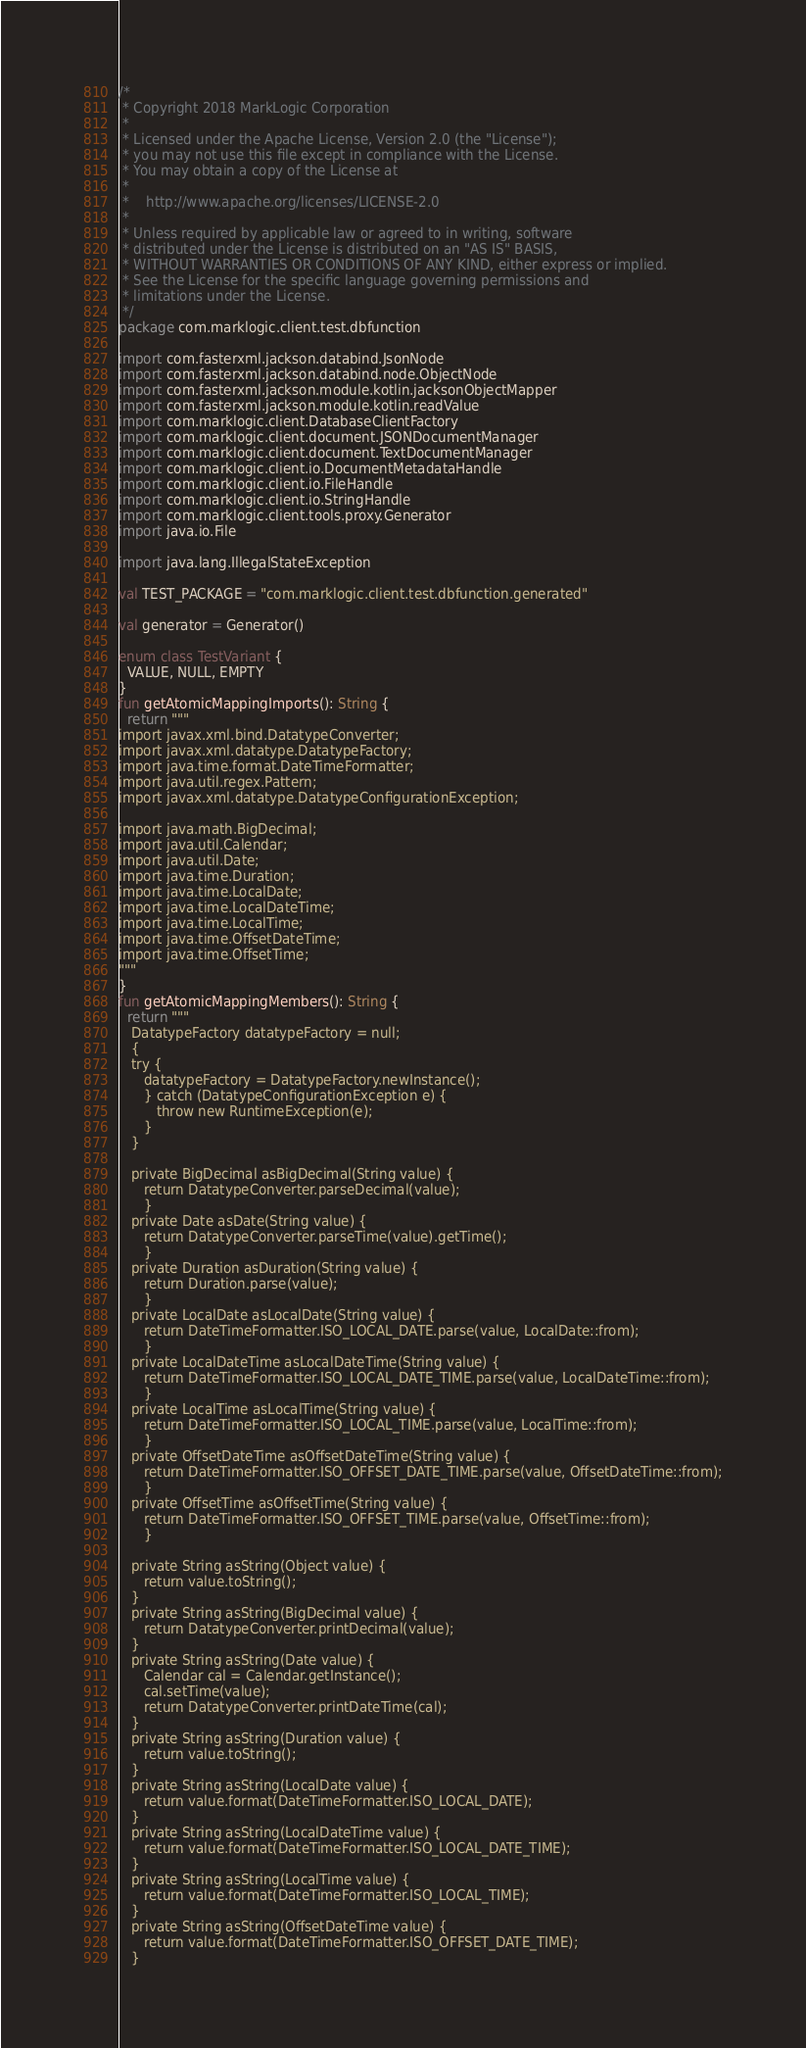<code> <loc_0><loc_0><loc_500><loc_500><_Kotlin_>/*
 * Copyright 2018 MarkLogic Corporation
 *
 * Licensed under the Apache License, Version 2.0 (the "License");
 * you may not use this file except in compliance with the License.
 * You may obtain a copy of the License at
 *
 *    http://www.apache.org/licenses/LICENSE-2.0
 *
 * Unless required by applicable law or agreed to in writing, software
 * distributed under the License is distributed on an "AS IS" BASIS,
 * WITHOUT WARRANTIES OR CONDITIONS OF ANY KIND, either express or implied.
 * See the License for the specific language governing permissions and
 * limitations under the License.
 */
package com.marklogic.client.test.dbfunction

import com.fasterxml.jackson.databind.JsonNode
import com.fasterxml.jackson.databind.node.ObjectNode
import com.fasterxml.jackson.module.kotlin.jacksonObjectMapper
import com.fasterxml.jackson.module.kotlin.readValue
import com.marklogic.client.DatabaseClientFactory
import com.marklogic.client.document.JSONDocumentManager
import com.marklogic.client.document.TextDocumentManager
import com.marklogic.client.io.DocumentMetadataHandle
import com.marklogic.client.io.FileHandle
import com.marklogic.client.io.StringHandle
import com.marklogic.client.tools.proxy.Generator
import java.io.File

import java.lang.IllegalStateException

val TEST_PACKAGE = "com.marklogic.client.test.dbfunction.generated"

val generator = Generator()

enum class TestVariant {
  VALUE, NULL, EMPTY
}
fun getAtomicMappingImports(): String {
  return """
import javax.xml.bind.DatatypeConverter;
import javax.xml.datatype.DatatypeFactory;
import java.time.format.DateTimeFormatter;
import java.util.regex.Pattern;
import javax.xml.datatype.DatatypeConfigurationException;

import java.math.BigDecimal;
import java.util.Calendar;
import java.util.Date;
import java.time.Duration;
import java.time.LocalDate;
import java.time.LocalDateTime;
import java.time.LocalTime;
import java.time.OffsetDateTime;
import java.time.OffsetTime;
"""
}
fun getAtomicMappingMembers(): String {
  return """
   DatatypeFactory datatypeFactory = null;
   {
   try {
      datatypeFactory = DatatypeFactory.newInstance();
      } catch (DatatypeConfigurationException e) {
         throw new RuntimeException(e);
      }
   }

   private BigDecimal asBigDecimal(String value) {
      return DatatypeConverter.parseDecimal(value);
      }
   private Date asDate(String value) {
      return DatatypeConverter.parseTime(value).getTime();
      }
   private Duration asDuration(String value) {
      return Duration.parse(value);
      }
   private LocalDate asLocalDate(String value) {
      return DateTimeFormatter.ISO_LOCAL_DATE.parse(value, LocalDate::from);
      }
   private LocalDateTime asLocalDateTime(String value) {
      return DateTimeFormatter.ISO_LOCAL_DATE_TIME.parse(value, LocalDateTime::from);
      }
   private LocalTime asLocalTime(String value) {
      return DateTimeFormatter.ISO_LOCAL_TIME.parse(value, LocalTime::from);
      }
   private OffsetDateTime asOffsetDateTime(String value) {
      return DateTimeFormatter.ISO_OFFSET_DATE_TIME.parse(value, OffsetDateTime::from);
      }
   private OffsetTime asOffsetTime(String value) {
      return DateTimeFormatter.ISO_OFFSET_TIME.parse(value, OffsetTime::from);
      }

   private String asString(Object value) {
      return value.toString();
   }
   private String asString(BigDecimal value) {
      return DatatypeConverter.printDecimal(value);
   }
   private String asString(Date value) {
      Calendar cal = Calendar.getInstance();
      cal.setTime(value);
      return DatatypeConverter.printDateTime(cal);
   }
   private String asString(Duration value) {
      return value.toString();
   }
   private String asString(LocalDate value) {
      return value.format(DateTimeFormatter.ISO_LOCAL_DATE);
   }
   private String asString(LocalDateTime value) {
      return value.format(DateTimeFormatter.ISO_LOCAL_DATE_TIME);
   }
   private String asString(LocalTime value) {
      return value.format(DateTimeFormatter.ISO_LOCAL_TIME);
   }
   private String asString(OffsetDateTime value) {
      return value.format(DateTimeFormatter.ISO_OFFSET_DATE_TIME);
   }</code> 